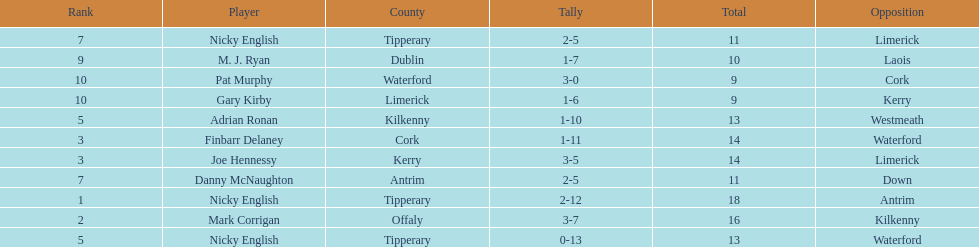What was the average of the totals of nicky english and mark corrigan? 17. 